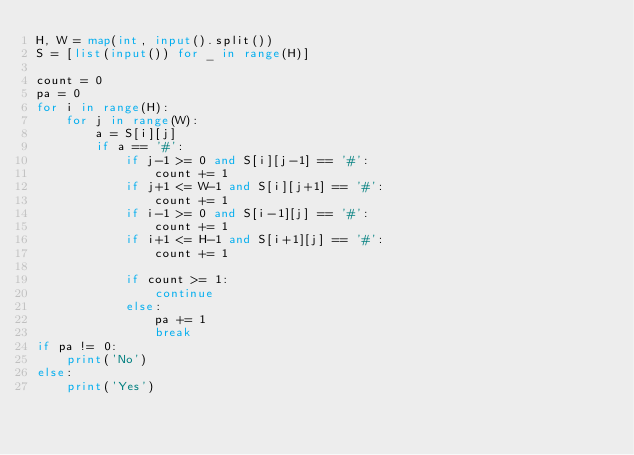<code> <loc_0><loc_0><loc_500><loc_500><_Python_>H, W = map(int, input().split())
S = [list(input()) for _ in range(H)]

count = 0
pa = 0
for i in range(H):
    for j in range(W):
        a = S[i][j]
        if a == '#':
            if j-1 >= 0 and S[i][j-1] == '#':
                count += 1
            if j+1 <= W-1 and S[i][j+1] == '#':
                count += 1
            if i-1 >= 0 and S[i-1][j] == '#':
                count += 1
            if i+1 <= H-1 and S[i+1][j] == '#':
                count += 1

            if count >= 1:
                continue
            else:
                pa += 1
                break
if pa != 0:
    print('No')
else:
    print('Yes')
</code> 